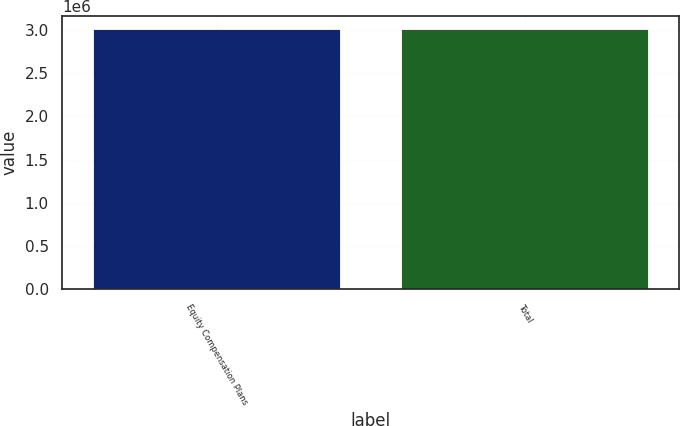<chart> <loc_0><loc_0><loc_500><loc_500><bar_chart><fcel>Equity Compensation Plans<fcel>Total<nl><fcel>3.00956e+06<fcel>3.00956e+06<nl></chart> 